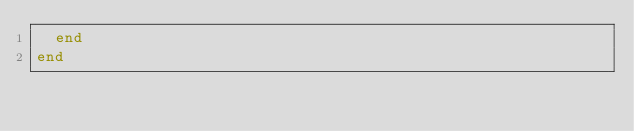<code> <loc_0><loc_0><loc_500><loc_500><_Ruby_>  end
end
</code> 